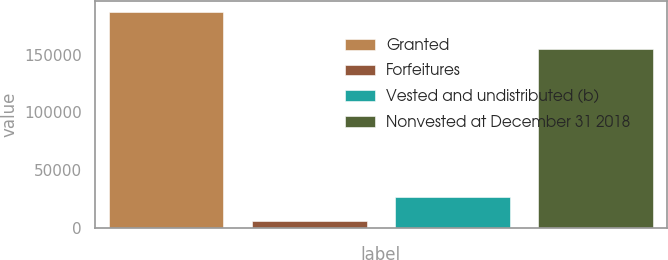<chart> <loc_0><loc_0><loc_500><loc_500><bar_chart><fcel>Granted<fcel>Forfeitures<fcel>Vested and undistributed (b)<fcel>Nonvested at December 31 2018<nl><fcel>187273<fcel>5463<fcel>26557<fcel>155253<nl></chart> 